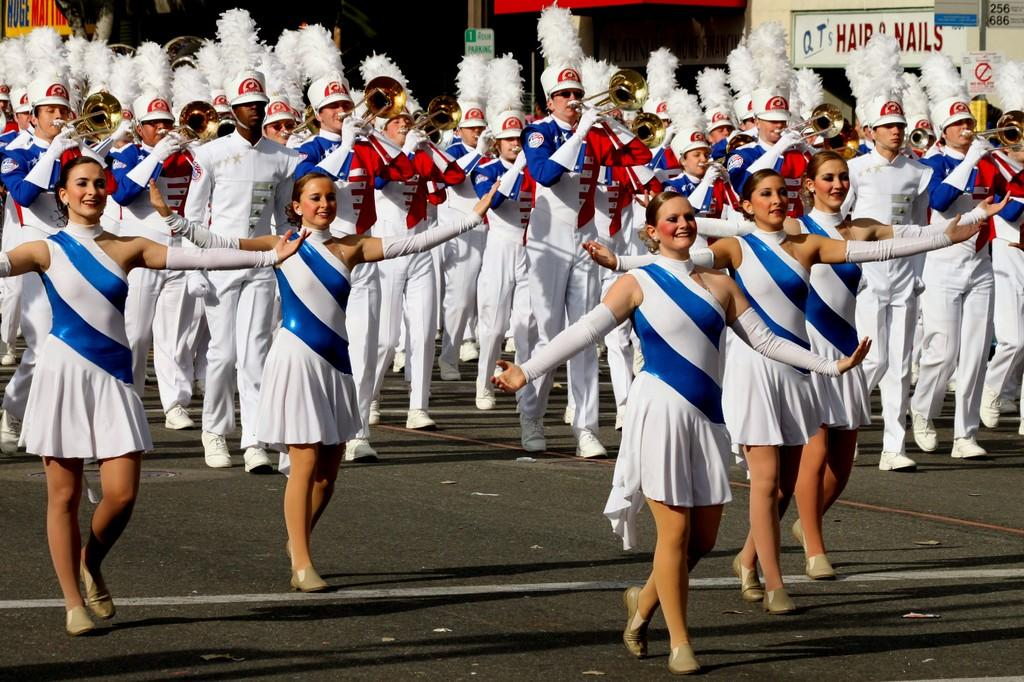Provide a one-sentence caption for the provided image. A marching band performs on the street in front of QT's Hair & Nails. 